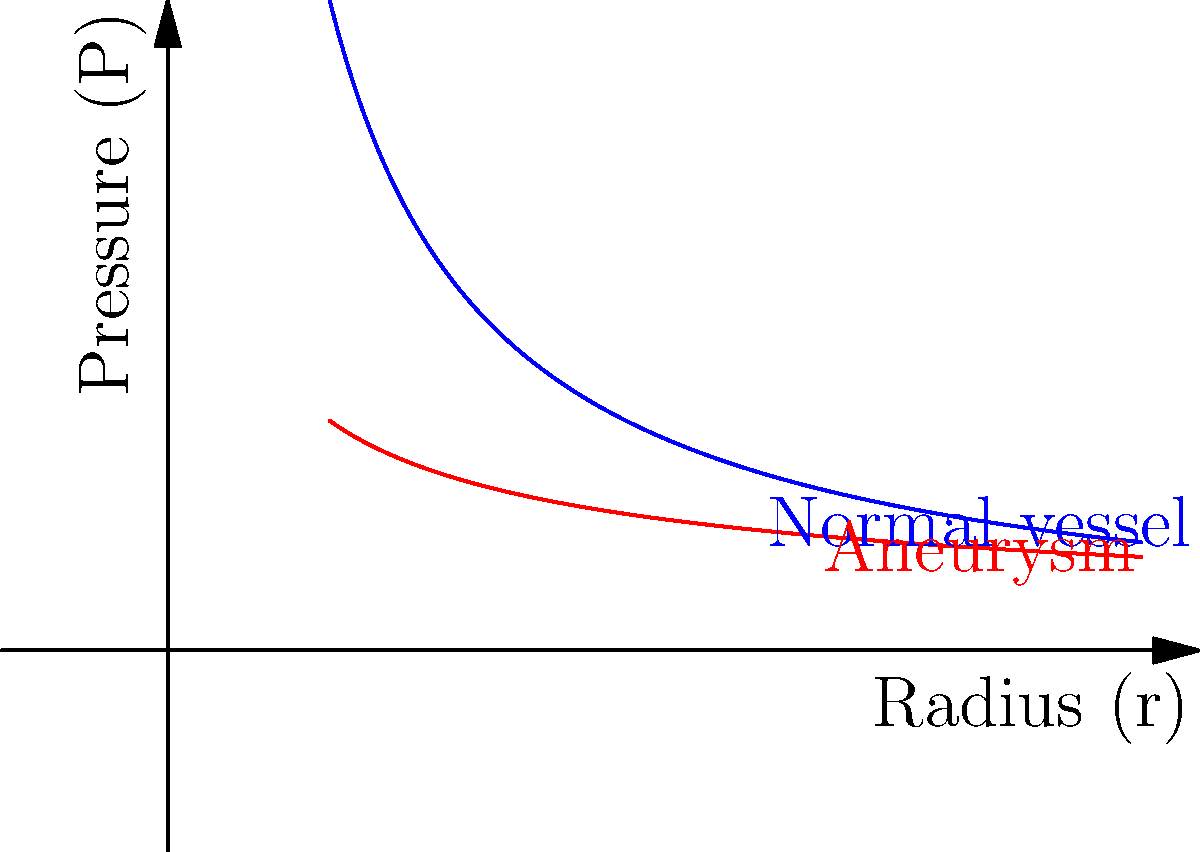Based on the graph showing pressure distribution in blood vessels, which mathematical relationship best describes the pressure-radius correlation in an aneurysm, and how does this differ from normal vessels in terms of wall stress? To answer this question, let's analyze the graph and the underlying principles step-by-step:

1. Normal blood vessel pressure distribution:
   - The blue curve represents normal vessels
   - It follows the equation $P = \frac{k}{r}$, where $P$ is pressure, $r$ is radius, and $k$ is a constant
   - This is derived from the Law of Laplace: $T = P \cdot r$, where $T$ is wall tension

2. Aneurysm pressure distribution:
   - The red curve represents the aneurysm
   - It follows a different pattern, approximated by $P = \frac{k}{\sqrt{r}}$

3. Comparing the curves:
   - The aneurysm curve decreases more slowly as radius increases
   - This means pressure drops less rapidly in an aneurysm as it expands

4. Wall stress implications:
   - In normal vessels, as radius increases, pressure decreases proportionally, maintaining constant wall stress
   - In aneurysms, pressure doesn't decrease as rapidly with increasing radius
   - This leads to higher wall stress in aneurysms as they expand

5. Clinical significance:
   - Higher wall stress in aneurysms increases the risk of rupture
   - This explains why larger aneurysms are generally at higher risk of rupture

Therefore, the pressure-radius relationship in aneurysms is best described by $P \propto \frac{1}{\sqrt{r}}$, which results in higher wall stress compared to normal vessels as the radius increases.
Answer: $P \propto \frac{1}{\sqrt{r}}$; higher wall stress with increasing radius 